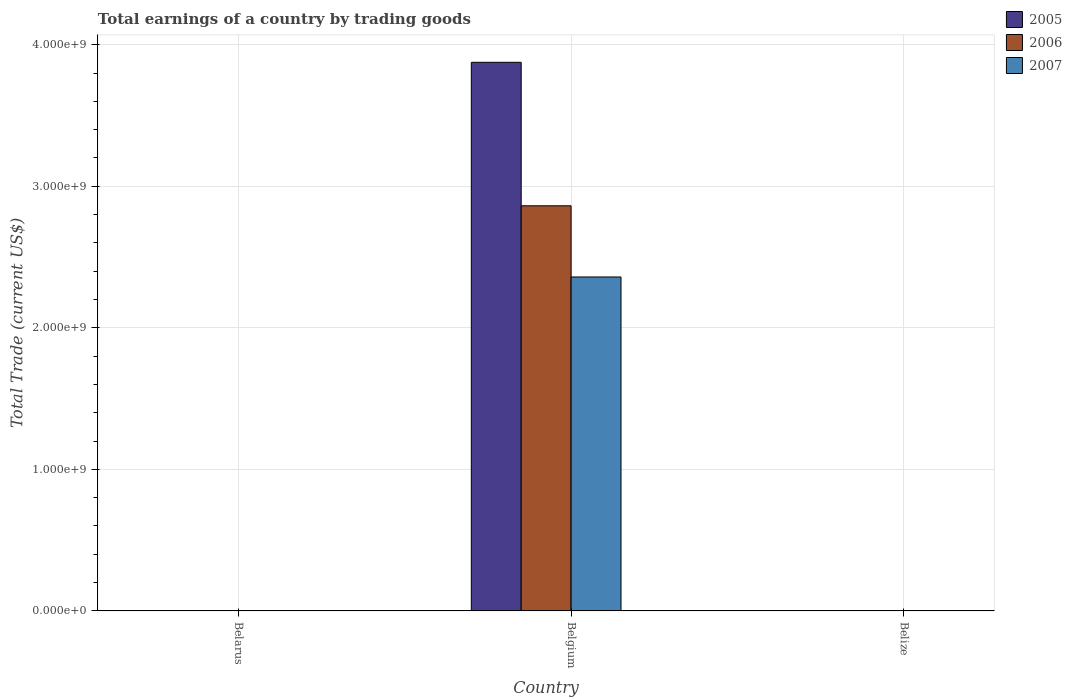How many different coloured bars are there?
Ensure brevity in your answer.  3. Are the number of bars per tick equal to the number of legend labels?
Offer a terse response. No. What is the label of the 1st group of bars from the left?
Make the answer very short. Belarus. What is the total earnings in 2007 in Belize?
Offer a very short reply. 0. Across all countries, what is the maximum total earnings in 2005?
Offer a terse response. 3.88e+09. Across all countries, what is the minimum total earnings in 2005?
Ensure brevity in your answer.  0. In which country was the total earnings in 2006 maximum?
Give a very brief answer. Belgium. What is the total total earnings in 2006 in the graph?
Provide a succinct answer. 2.86e+09. What is the average total earnings in 2007 per country?
Make the answer very short. 7.86e+08. What is the difference between the total earnings of/in 2005 and total earnings of/in 2006 in Belgium?
Your answer should be compact. 1.01e+09. What is the difference between the highest and the lowest total earnings in 2006?
Keep it short and to the point. 2.86e+09. In how many countries, is the total earnings in 2006 greater than the average total earnings in 2006 taken over all countries?
Offer a very short reply. 1. Are all the bars in the graph horizontal?
Ensure brevity in your answer.  No. How many countries are there in the graph?
Your answer should be compact. 3. Does the graph contain any zero values?
Your answer should be very brief. Yes. Does the graph contain grids?
Your response must be concise. Yes. How many legend labels are there?
Provide a succinct answer. 3. What is the title of the graph?
Your answer should be compact. Total earnings of a country by trading goods. Does "1967" appear as one of the legend labels in the graph?
Give a very brief answer. No. What is the label or title of the X-axis?
Provide a succinct answer. Country. What is the label or title of the Y-axis?
Keep it short and to the point. Total Trade (current US$). What is the Total Trade (current US$) of 2007 in Belarus?
Give a very brief answer. 0. What is the Total Trade (current US$) of 2005 in Belgium?
Provide a short and direct response. 3.88e+09. What is the Total Trade (current US$) in 2006 in Belgium?
Provide a succinct answer. 2.86e+09. What is the Total Trade (current US$) in 2007 in Belgium?
Provide a succinct answer. 2.36e+09. What is the Total Trade (current US$) of 2007 in Belize?
Give a very brief answer. 0. Across all countries, what is the maximum Total Trade (current US$) of 2005?
Keep it short and to the point. 3.88e+09. Across all countries, what is the maximum Total Trade (current US$) in 2006?
Ensure brevity in your answer.  2.86e+09. Across all countries, what is the maximum Total Trade (current US$) of 2007?
Your response must be concise. 2.36e+09. Across all countries, what is the minimum Total Trade (current US$) of 2006?
Keep it short and to the point. 0. Across all countries, what is the minimum Total Trade (current US$) in 2007?
Offer a terse response. 0. What is the total Total Trade (current US$) in 2005 in the graph?
Provide a short and direct response. 3.88e+09. What is the total Total Trade (current US$) in 2006 in the graph?
Provide a short and direct response. 2.86e+09. What is the total Total Trade (current US$) of 2007 in the graph?
Your response must be concise. 2.36e+09. What is the average Total Trade (current US$) of 2005 per country?
Your answer should be very brief. 1.29e+09. What is the average Total Trade (current US$) in 2006 per country?
Ensure brevity in your answer.  9.54e+08. What is the average Total Trade (current US$) of 2007 per country?
Ensure brevity in your answer.  7.86e+08. What is the difference between the Total Trade (current US$) in 2005 and Total Trade (current US$) in 2006 in Belgium?
Offer a terse response. 1.01e+09. What is the difference between the Total Trade (current US$) in 2005 and Total Trade (current US$) in 2007 in Belgium?
Offer a very short reply. 1.52e+09. What is the difference between the Total Trade (current US$) in 2006 and Total Trade (current US$) in 2007 in Belgium?
Give a very brief answer. 5.03e+08. What is the difference between the highest and the lowest Total Trade (current US$) of 2005?
Your answer should be very brief. 3.88e+09. What is the difference between the highest and the lowest Total Trade (current US$) of 2006?
Give a very brief answer. 2.86e+09. What is the difference between the highest and the lowest Total Trade (current US$) in 2007?
Your answer should be compact. 2.36e+09. 